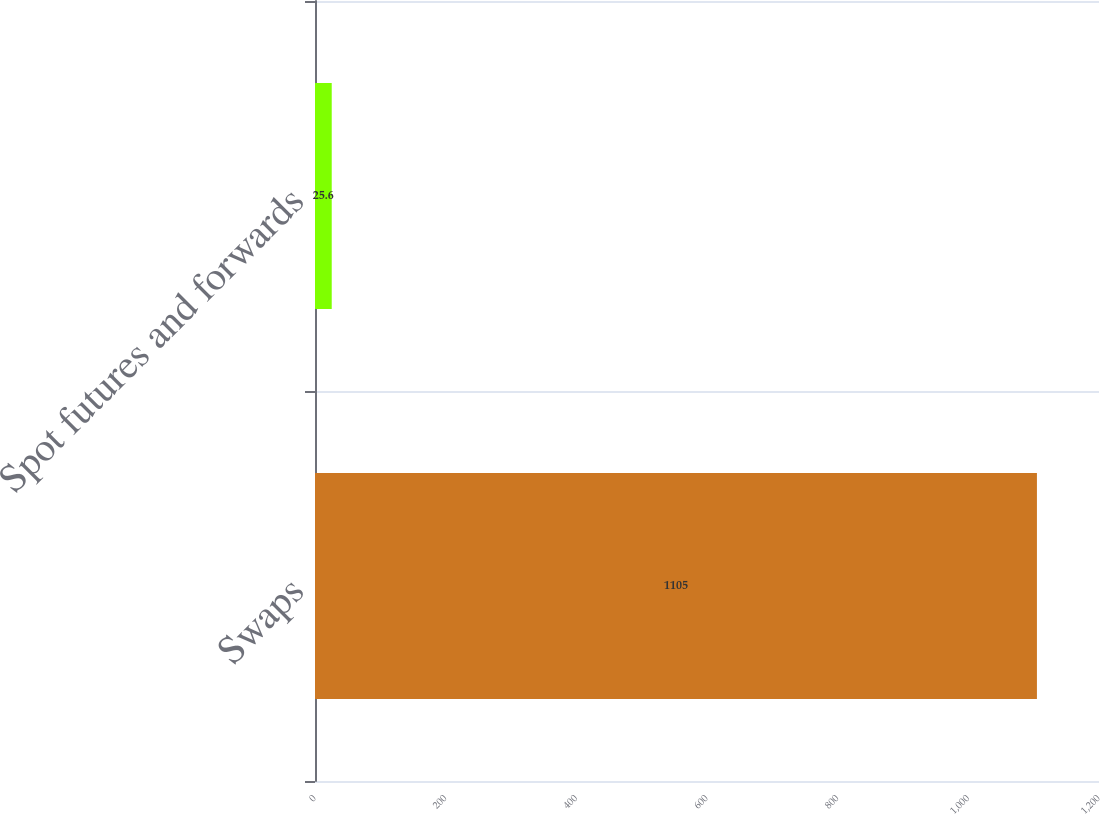Convert chart. <chart><loc_0><loc_0><loc_500><loc_500><bar_chart><fcel>Swaps<fcel>Spot futures and forwards<nl><fcel>1105<fcel>25.6<nl></chart> 